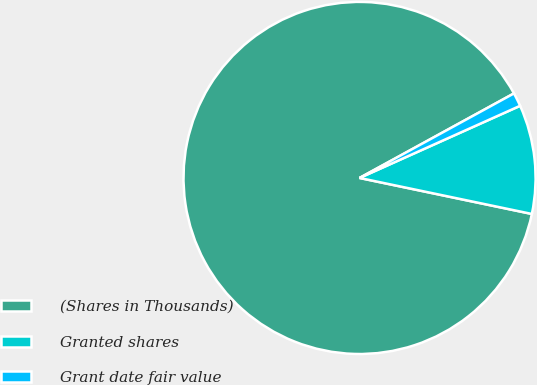Convert chart. <chart><loc_0><loc_0><loc_500><loc_500><pie_chart><fcel>(Shares in Thousands)<fcel>Granted shares<fcel>Grant date fair value<nl><fcel>88.75%<fcel>10.0%<fcel>1.25%<nl></chart> 